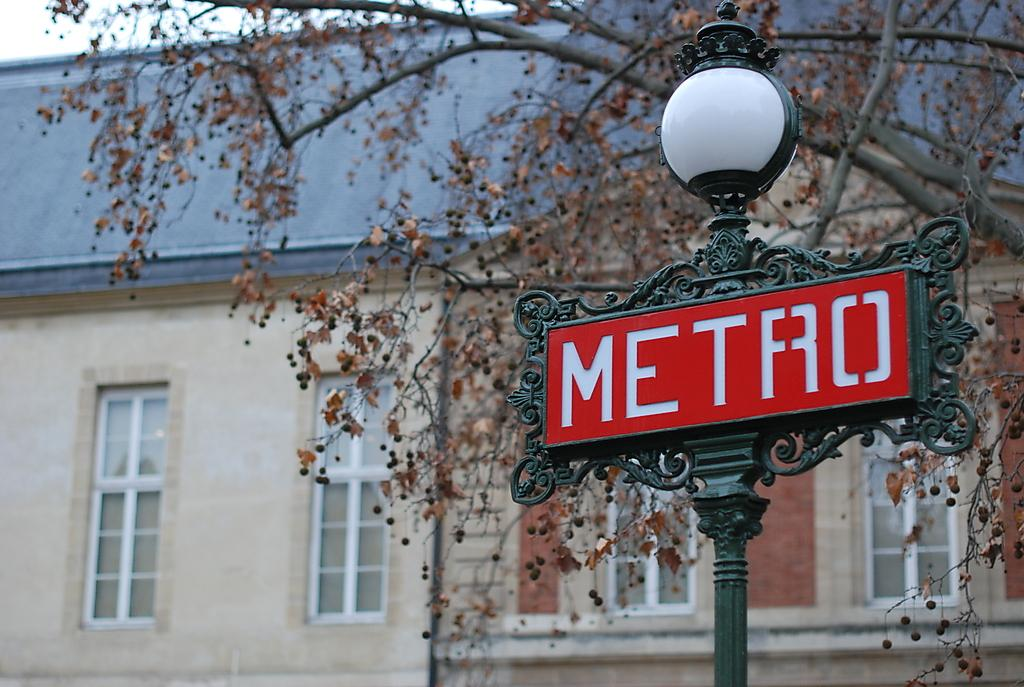What is located in the foreground of the image? There is a light pole and a board in the foreground of the image. What can be seen in the background of the image? There is a tree, a house, and windows visible in the background of the image. What is visible in the top left corner of the image? The sky is visible in the top left corner of the image. Can you describe the time of day when the image was taken? The image was taken during the day. Can you tell me how many friends are depicted in the image? There are no friends present in the image. What type of creature is shown interacting with the tree in the background of the image? There is no creature shown interacting with the tree in the background of the image; only the tree and house are present. 